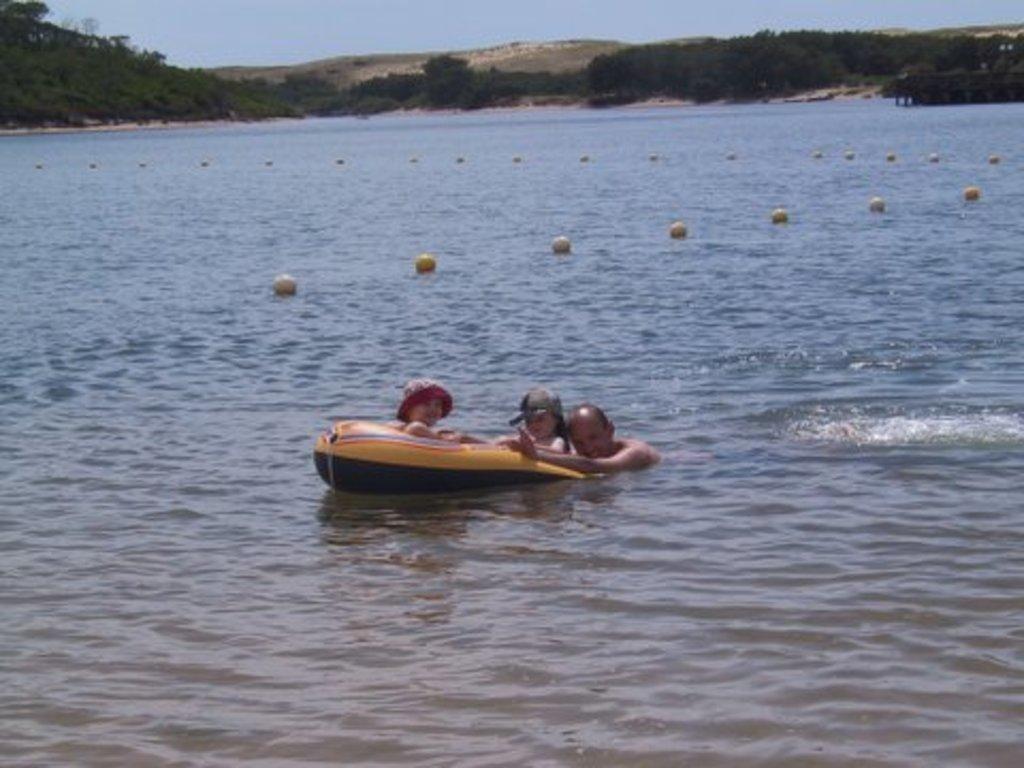Please provide a concise description of this image. In this picture there is a water body. In the middle of the picture we can see three persons. In the center of the picture there are trees, shrubs on the hills. At the top there is sky. 